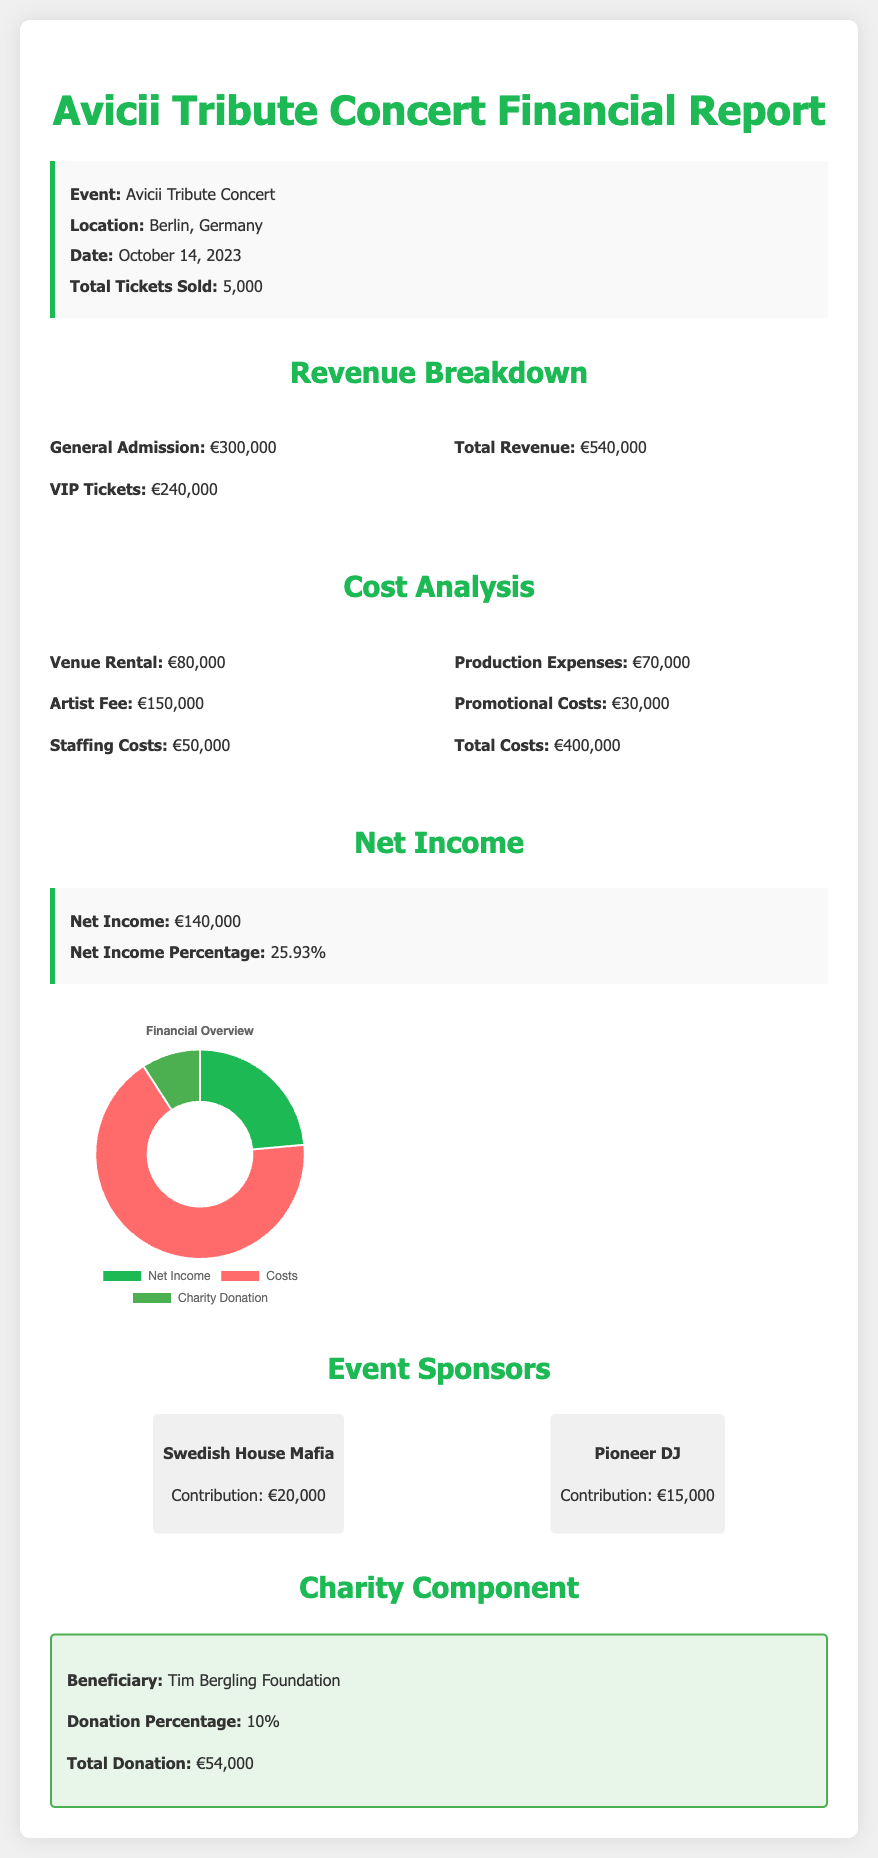What is the total revenue? The total revenue is specified in the document as the sum of general admission and VIP tickets, which adds up to €540,000.
Answer: €540,000 What are the total costs? The total costs are detailed in the document, totaling €400,000 from various expenditures.
Answer: €400,000 What is the net income? The net income is clearly stated in the document as what remains after costs are deducted from total revenue, which is €140,000.
Answer: €140,000 How many tickets were sold? The document indicates the total number of tickets sold, which is a key metric for the event's financials.
Answer: 5,000 What is the donation percentage? The document specifies that the donation percentage for the charity is an important aspect of the financial overview.
Answer: 10% What was the artist fee? The artist fee is outlined in the cost analysis section, showcasing how much was allocated for the artist.
Answer: €150,000 What is the net income percentage? The net income percentage indicates how much of the total revenue is profit and is stated in the report as a percentage figure.
Answer: 25.93% What was the venue rental cost? The cost for venue rental is provided in the cost analysis section, highlighting a significant expense for the event.
Answer: €80,000 Who is the beneficiary of the charity component? The document notes that the Tim Bergling Foundation is the designated beneficiary for the charity donations made during the event.
Answer: Tim Bergling Foundation 